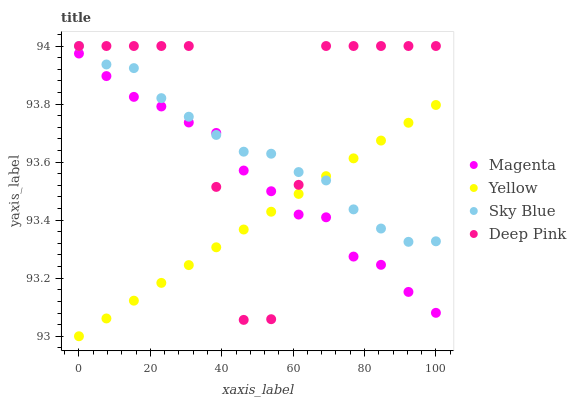Does Yellow have the minimum area under the curve?
Answer yes or no. Yes. Does Deep Pink have the maximum area under the curve?
Answer yes or no. Yes. Does Magenta have the minimum area under the curve?
Answer yes or no. No. Does Magenta have the maximum area under the curve?
Answer yes or no. No. Is Yellow the smoothest?
Answer yes or no. Yes. Is Deep Pink the roughest?
Answer yes or no. Yes. Is Magenta the smoothest?
Answer yes or no. No. Is Magenta the roughest?
Answer yes or no. No. Does Yellow have the lowest value?
Answer yes or no. Yes. Does Magenta have the lowest value?
Answer yes or no. No. Does Deep Pink have the highest value?
Answer yes or no. Yes. Does Magenta have the highest value?
Answer yes or no. No. Does Sky Blue intersect Magenta?
Answer yes or no. Yes. Is Sky Blue less than Magenta?
Answer yes or no. No. Is Sky Blue greater than Magenta?
Answer yes or no. No. 